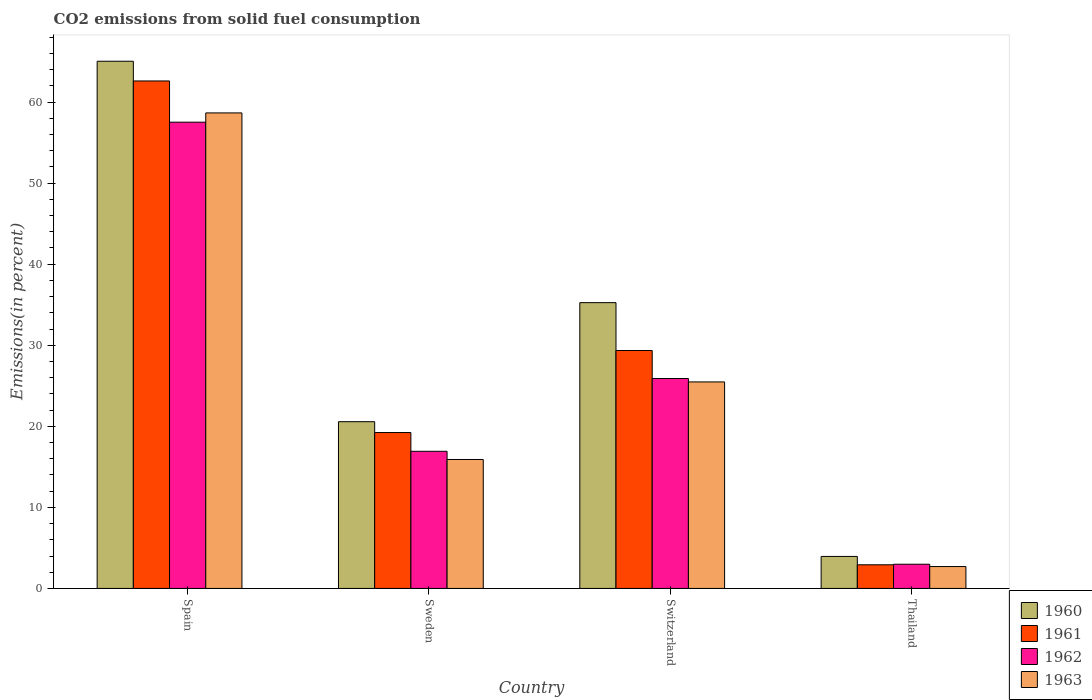How many bars are there on the 3rd tick from the left?
Your answer should be compact. 4. What is the label of the 1st group of bars from the left?
Offer a very short reply. Spain. What is the total CO2 emitted in 1961 in Spain?
Keep it short and to the point. 62.6. Across all countries, what is the maximum total CO2 emitted in 1962?
Give a very brief answer. 57.52. Across all countries, what is the minimum total CO2 emitted in 1961?
Provide a short and direct response. 2.92. In which country was the total CO2 emitted in 1960 minimum?
Ensure brevity in your answer.  Thailand. What is the total total CO2 emitted in 1960 in the graph?
Keep it short and to the point. 124.81. What is the difference between the total CO2 emitted in 1962 in Switzerland and that in Thailand?
Provide a short and direct response. 22.91. What is the difference between the total CO2 emitted in 1961 in Sweden and the total CO2 emitted in 1963 in Spain?
Your answer should be very brief. -39.43. What is the average total CO2 emitted in 1963 per country?
Give a very brief answer. 25.69. What is the difference between the total CO2 emitted of/in 1963 and total CO2 emitted of/in 1961 in Switzerland?
Provide a succinct answer. -3.88. In how many countries, is the total CO2 emitted in 1963 greater than 22 %?
Your response must be concise. 2. What is the ratio of the total CO2 emitted in 1963 in Sweden to that in Switzerland?
Your answer should be compact. 0.62. Is the total CO2 emitted in 1960 in Sweden less than that in Switzerland?
Your answer should be very brief. Yes. What is the difference between the highest and the second highest total CO2 emitted in 1961?
Give a very brief answer. -10.12. What is the difference between the highest and the lowest total CO2 emitted in 1960?
Your answer should be very brief. 61.09. Is the sum of the total CO2 emitted in 1960 in Sweden and Switzerland greater than the maximum total CO2 emitted in 1963 across all countries?
Offer a terse response. No. What does the 2nd bar from the left in Thailand represents?
Your response must be concise. 1961. What does the 2nd bar from the right in Spain represents?
Your response must be concise. 1962. How many bars are there?
Keep it short and to the point. 16. Are all the bars in the graph horizontal?
Make the answer very short. No. What is the difference between two consecutive major ticks on the Y-axis?
Offer a very short reply. 10. Does the graph contain any zero values?
Provide a succinct answer. No. How many legend labels are there?
Your answer should be very brief. 4. What is the title of the graph?
Keep it short and to the point. CO2 emissions from solid fuel consumption. What is the label or title of the Y-axis?
Your answer should be compact. Emissions(in percent). What is the Emissions(in percent) in 1960 in Spain?
Offer a terse response. 65.04. What is the Emissions(in percent) of 1961 in Spain?
Ensure brevity in your answer.  62.6. What is the Emissions(in percent) of 1962 in Spain?
Your response must be concise. 57.52. What is the Emissions(in percent) in 1963 in Spain?
Ensure brevity in your answer.  58.66. What is the Emissions(in percent) of 1960 in Sweden?
Keep it short and to the point. 20.57. What is the Emissions(in percent) of 1961 in Sweden?
Your answer should be compact. 19.23. What is the Emissions(in percent) in 1962 in Sweden?
Your response must be concise. 16.92. What is the Emissions(in percent) in 1963 in Sweden?
Ensure brevity in your answer.  15.91. What is the Emissions(in percent) of 1960 in Switzerland?
Your response must be concise. 35.26. What is the Emissions(in percent) in 1961 in Switzerland?
Offer a terse response. 29.35. What is the Emissions(in percent) of 1962 in Switzerland?
Offer a very short reply. 25.9. What is the Emissions(in percent) in 1963 in Switzerland?
Your response must be concise. 25.48. What is the Emissions(in percent) of 1960 in Thailand?
Provide a succinct answer. 3.95. What is the Emissions(in percent) of 1961 in Thailand?
Provide a succinct answer. 2.92. What is the Emissions(in percent) in 1962 in Thailand?
Ensure brevity in your answer.  2.99. What is the Emissions(in percent) in 1963 in Thailand?
Make the answer very short. 2.7. Across all countries, what is the maximum Emissions(in percent) in 1960?
Make the answer very short. 65.04. Across all countries, what is the maximum Emissions(in percent) of 1961?
Give a very brief answer. 62.6. Across all countries, what is the maximum Emissions(in percent) in 1962?
Keep it short and to the point. 57.52. Across all countries, what is the maximum Emissions(in percent) in 1963?
Keep it short and to the point. 58.66. Across all countries, what is the minimum Emissions(in percent) in 1960?
Keep it short and to the point. 3.95. Across all countries, what is the minimum Emissions(in percent) of 1961?
Provide a short and direct response. 2.92. Across all countries, what is the minimum Emissions(in percent) of 1962?
Your answer should be very brief. 2.99. Across all countries, what is the minimum Emissions(in percent) of 1963?
Your response must be concise. 2.7. What is the total Emissions(in percent) of 1960 in the graph?
Offer a very short reply. 124.81. What is the total Emissions(in percent) of 1961 in the graph?
Offer a terse response. 114.11. What is the total Emissions(in percent) of 1962 in the graph?
Offer a terse response. 103.32. What is the total Emissions(in percent) of 1963 in the graph?
Your response must be concise. 102.74. What is the difference between the Emissions(in percent) of 1960 in Spain and that in Sweden?
Your response must be concise. 44.47. What is the difference between the Emissions(in percent) of 1961 in Spain and that in Sweden?
Make the answer very short. 43.37. What is the difference between the Emissions(in percent) in 1962 in Spain and that in Sweden?
Make the answer very short. 40.6. What is the difference between the Emissions(in percent) in 1963 in Spain and that in Sweden?
Provide a succinct answer. 42.75. What is the difference between the Emissions(in percent) of 1960 in Spain and that in Switzerland?
Ensure brevity in your answer.  29.78. What is the difference between the Emissions(in percent) of 1961 in Spain and that in Switzerland?
Provide a short and direct response. 33.25. What is the difference between the Emissions(in percent) in 1962 in Spain and that in Switzerland?
Make the answer very short. 31.62. What is the difference between the Emissions(in percent) in 1963 in Spain and that in Switzerland?
Make the answer very short. 33.19. What is the difference between the Emissions(in percent) in 1960 in Spain and that in Thailand?
Make the answer very short. 61.09. What is the difference between the Emissions(in percent) in 1961 in Spain and that in Thailand?
Your answer should be compact. 59.69. What is the difference between the Emissions(in percent) in 1962 in Spain and that in Thailand?
Keep it short and to the point. 54.53. What is the difference between the Emissions(in percent) in 1963 in Spain and that in Thailand?
Offer a very short reply. 55.96. What is the difference between the Emissions(in percent) of 1960 in Sweden and that in Switzerland?
Your response must be concise. -14.69. What is the difference between the Emissions(in percent) in 1961 in Sweden and that in Switzerland?
Provide a short and direct response. -10.12. What is the difference between the Emissions(in percent) of 1962 in Sweden and that in Switzerland?
Provide a short and direct response. -8.98. What is the difference between the Emissions(in percent) in 1963 in Sweden and that in Switzerland?
Ensure brevity in your answer.  -9.57. What is the difference between the Emissions(in percent) of 1960 in Sweden and that in Thailand?
Provide a short and direct response. 16.62. What is the difference between the Emissions(in percent) in 1961 in Sweden and that in Thailand?
Your answer should be very brief. 16.31. What is the difference between the Emissions(in percent) in 1962 in Sweden and that in Thailand?
Your answer should be very brief. 13.93. What is the difference between the Emissions(in percent) of 1963 in Sweden and that in Thailand?
Make the answer very short. 13.21. What is the difference between the Emissions(in percent) of 1960 in Switzerland and that in Thailand?
Give a very brief answer. 31.31. What is the difference between the Emissions(in percent) in 1961 in Switzerland and that in Thailand?
Make the answer very short. 26.43. What is the difference between the Emissions(in percent) of 1962 in Switzerland and that in Thailand?
Ensure brevity in your answer.  22.91. What is the difference between the Emissions(in percent) in 1963 in Switzerland and that in Thailand?
Provide a short and direct response. 22.78. What is the difference between the Emissions(in percent) in 1960 in Spain and the Emissions(in percent) in 1961 in Sweden?
Ensure brevity in your answer.  45.81. What is the difference between the Emissions(in percent) in 1960 in Spain and the Emissions(in percent) in 1962 in Sweden?
Offer a very short reply. 48.12. What is the difference between the Emissions(in percent) of 1960 in Spain and the Emissions(in percent) of 1963 in Sweden?
Your answer should be very brief. 49.13. What is the difference between the Emissions(in percent) of 1961 in Spain and the Emissions(in percent) of 1962 in Sweden?
Give a very brief answer. 45.69. What is the difference between the Emissions(in percent) of 1961 in Spain and the Emissions(in percent) of 1963 in Sweden?
Offer a terse response. 46.7. What is the difference between the Emissions(in percent) of 1962 in Spain and the Emissions(in percent) of 1963 in Sweden?
Your answer should be very brief. 41.61. What is the difference between the Emissions(in percent) of 1960 in Spain and the Emissions(in percent) of 1961 in Switzerland?
Keep it short and to the point. 35.69. What is the difference between the Emissions(in percent) of 1960 in Spain and the Emissions(in percent) of 1962 in Switzerland?
Ensure brevity in your answer.  39.14. What is the difference between the Emissions(in percent) of 1960 in Spain and the Emissions(in percent) of 1963 in Switzerland?
Your answer should be compact. 39.56. What is the difference between the Emissions(in percent) in 1961 in Spain and the Emissions(in percent) in 1962 in Switzerland?
Offer a terse response. 36.7. What is the difference between the Emissions(in percent) of 1961 in Spain and the Emissions(in percent) of 1963 in Switzerland?
Offer a terse response. 37.13. What is the difference between the Emissions(in percent) in 1962 in Spain and the Emissions(in percent) in 1963 in Switzerland?
Your answer should be compact. 32.04. What is the difference between the Emissions(in percent) of 1960 in Spain and the Emissions(in percent) of 1961 in Thailand?
Provide a succinct answer. 62.12. What is the difference between the Emissions(in percent) in 1960 in Spain and the Emissions(in percent) in 1962 in Thailand?
Ensure brevity in your answer.  62.05. What is the difference between the Emissions(in percent) of 1960 in Spain and the Emissions(in percent) of 1963 in Thailand?
Offer a very short reply. 62.34. What is the difference between the Emissions(in percent) of 1961 in Spain and the Emissions(in percent) of 1962 in Thailand?
Make the answer very short. 59.62. What is the difference between the Emissions(in percent) in 1961 in Spain and the Emissions(in percent) in 1963 in Thailand?
Your response must be concise. 59.91. What is the difference between the Emissions(in percent) in 1962 in Spain and the Emissions(in percent) in 1963 in Thailand?
Make the answer very short. 54.82. What is the difference between the Emissions(in percent) of 1960 in Sweden and the Emissions(in percent) of 1961 in Switzerland?
Keep it short and to the point. -8.78. What is the difference between the Emissions(in percent) in 1960 in Sweden and the Emissions(in percent) in 1962 in Switzerland?
Your answer should be very brief. -5.33. What is the difference between the Emissions(in percent) in 1960 in Sweden and the Emissions(in percent) in 1963 in Switzerland?
Your answer should be very brief. -4.91. What is the difference between the Emissions(in percent) in 1961 in Sweden and the Emissions(in percent) in 1962 in Switzerland?
Keep it short and to the point. -6.67. What is the difference between the Emissions(in percent) of 1961 in Sweden and the Emissions(in percent) of 1963 in Switzerland?
Make the answer very short. -6.24. What is the difference between the Emissions(in percent) of 1962 in Sweden and the Emissions(in percent) of 1963 in Switzerland?
Make the answer very short. -8.56. What is the difference between the Emissions(in percent) in 1960 in Sweden and the Emissions(in percent) in 1961 in Thailand?
Ensure brevity in your answer.  17.65. What is the difference between the Emissions(in percent) in 1960 in Sweden and the Emissions(in percent) in 1962 in Thailand?
Your response must be concise. 17.58. What is the difference between the Emissions(in percent) in 1960 in Sweden and the Emissions(in percent) in 1963 in Thailand?
Your answer should be compact. 17.87. What is the difference between the Emissions(in percent) of 1961 in Sweden and the Emissions(in percent) of 1962 in Thailand?
Offer a terse response. 16.25. What is the difference between the Emissions(in percent) of 1961 in Sweden and the Emissions(in percent) of 1963 in Thailand?
Ensure brevity in your answer.  16.53. What is the difference between the Emissions(in percent) of 1962 in Sweden and the Emissions(in percent) of 1963 in Thailand?
Provide a succinct answer. 14.22. What is the difference between the Emissions(in percent) in 1960 in Switzerland and the Emissions(in percent) in 1961 in Thailand?
Provide a succinct answer. 32.34. What is the difference between the Emissions(in percent) of 1960 in Switzerland and the Emissions(in percent) of 1962 in Thailand?
Provide a short and direct response. 32.27. What is the difference between the Emissions(in percent) in 1960 in Switzerland and the Emissions(in percent) in 1963 in Thailand?
Ensure brevity in your answer.  32.56. What is the difference between the Emissions(in percent) in 1961 in Switzerland and the Emissions(in percent) in 1962 in Thailand?
Your answer should be compact. 26.37. What is the difference between the Emissions(in percent) in 1961 in Switzerland and the Emissions(in percent) in 1963 in Thailand?
Your answer should be very brief. 26.65. What is the difference between the Emissions(in percent) in 1962 in Switzerland and the Emissions(in percent) in 1963 in Thailand?
Offer a terse response. 23.2. What is the average Emissions(in percent) in 1960 per country?
Provide a short and direct response. 31.2. What is the average Emissions(in percent) in 1961 per country?
Make the answer very short. 28.53. What is the average Emissions(in percent) in 1962 per country?
Provide a short and direct response. 25.83. What is the average Emissions(in percent) in 1963 per country?
Provide a short and direct response. 25.69. What is the difference between the Emissions(in percent) of 1960 and Emissions(in percent) of 1961 in Spain?
Offer a terse response. 2.43. What is the difference between the Emissions(in percent) in 1960 and Emissions(in percent) in 1962 in Spain?
Keep it short and to the point. 7.52. What is the difference between the Emissions(in percent) of 1960 and Emissions(in percent) of 1963 in Spain?
Offer a terse response. 6.38. What is the difference between the Emissions(in percent) of 1961 and Emissions(in percent) of 1962 in Spain?
Offer a terse response. 5.08. What is the difference between the Emissions(in percent) of 1961 and Emissions(in percent) of 1963 in Spain?
Provide a succinct answer. 3.94. What is the difference between the Emissions(in percent) in 1962 and Emissions(in percent) in 1963 in Spain?
Your answer should be very brief. -1.14. What is the difference between the Emissions(in percent) in 1960 and Emissions(in percent) in 1961 in Sweden?
Provide a short and direct response. 1.34. What is the difference between the Emissions(in percent) of 1960 and Emissions(in percent) of 1962 in Sweden?
Make the answer very short. 3.65. What is the difference between the Emissions(in percent) in 1960 and Emissions(in percent) in 1963 in Sweden?
Provide a succinct answer. 4.66. What is the difference between the Emissions(in percent) of 1961 and Emissions(in percent) of 1962 in Sweden?
Make the answer very short. 2.31. What is the difference between the Emissions(in percent) in 1961 and Emissions(in percent) in 1963 in Sweden?
Make the answer very short. 3.32. What is the difference between the Emissions(in percent) in 1962 and Emissions(in percent) in 1963 in Sweden?
Your answer should be compact. 1.01. What is the difference between the Emissions(in percent) of 1960 and Emissions(in percent) of 1961 in Switzerland?
Your answer should be compact. 5.9. What is the difference between the Emissions(in percent) in 1960 and Emissions(in percent) in 1962 in Switzerland?
Offer a very short reply. 9.36. What is the difference between the Emissions(in percent) of 1960 and Emissions(in percent) of 1963 in Switzerland?
Give a very brief answer. 9.78. What is the difference between the Emissions(in percent) in 1961 and Emissions(in percent) in 1962 in Switzerland?
Your answer should be compact. 3.45. What is the difference between the Emissions(in percent) of 1961 and Emissions(in percent) of 1963 in Switzerland?
Make the answer very short. 3.88. What is the difference between the Emissions(in percent) in 1962 and Emissions(in percent) in 1963 in Switzerland?
Provide a succinct answer. 0.42. What is the difference between the Emissions(in percent) of 1960 and Emissions(in percent) of 1961 in Thailand?
Give a very brief answer. 1.03. What is the difference between the Emissions(in percent) of 1960 and Emissions(in percent) of 1962 in Thailand?
Offer a terse response. 0.96. What is the difference between the Emissions(in percent) in 1960 and Emissions(in percent) in 1963 in Thailand?
Your answer should be compact. 1.25. What is the difference between the Emissions(in percent) in 1961 and Emissions(in percent) in 1962 in Thailand?
Provide a short and direct response. -0.07. What is the difference between the Emissions(in percent) of 1961 and Emissions(in percent) of 1963 in Thailand?
Offer a very short reply. 0.22. What is the difference between the Emissions(in percent) in 1962 and Emissions(in percent) in 1963 in Thailand?
Offer a very short reply. 0.29. What is the ratio of the Emissions(in percent) in 1960 in Spain to that in Sweden?
Ensure brevity in your answer.  3.16. What is the ratio of the Emissions(in percent) of 1961 in Spain to that in Sweden?
Your response must be concise. 3.26. What is the ratio of the Emissions(in percent) in 1962 in Spain to that in Sweden?
Keep it short and to the point. 3.4. What is the ratio of the Emissions(in percent) in 1963 in Spain to that in Sweden?
Ensure brevity in your answer.  3.69. What is the ratio of the Emissions(in percent) in 1960 in Spain to that in Switzerland?
Offer a very short reply. 1.84. What is the ratio of the Emissions(in percent) in 1961 in Spain to that in Switzerland?
Your answer should be compact. 2.13. What is the ratio of the Emissions(in percent) in 1962 in Spain to that in Switzerland?
Keep it short and to the point. 2.22. What is the ratio of the Emissions(in percent) in 1963 in Spain to that in Switzerland?
Offer a terse response. 2.3. What is the ratio of the Emissions(in percent) in 1960 in Spain to that in Thailand?
Keep it short and to the point. 16.47. What is the ratio of the Emissions(in percent) in 1961 in Spain to that in Thailand?
Provide a succinct answer. 21.46. What is the ratio of the Emissions(in percent) in 1962 in Spain to that in Thailand?
Provide a short and direct response. 19.26. What is the ratio of the Emissions(in percent) of 1963 in Spain to that in Thailand?
Provide a succinct answer. 21.73. What is the ratio of the Emissions(in percent) in 1960 in Sweden to that in Switzerland?
Make the answer very short. 0.58. What is the ratio of the Emissions(in percent) of 1961 in Sweden to that in Switzerland?
Keep it short and to the point. 0.66. What is the ratio of the Emissions(in percent) in 1962 in Sweden to that in Switzerland?
Keep it short and to the point. 0.65. What is the ratio of the Emissions(in percent) of 1963 in Sweden to that in Switzerland?
Provide a short and direct response. 0.62. What is the ratio of the Emissions(in percent) in 1960 in Sweden to that in Thailand?
Offer a very short reply. 5.21. What is the ratio of the Emissions(in percent) in 1961 in Sweden to that in Thailand?
Make the answer very short. 6.59. What is the ratio of the Emissions(in percent) in 1962 in Sweden to that in Thailand?
Offer a very short reply. 5.67. What is the ratio of the Emissions(in percent) in 1963 in Sweden to that in Thailand?
Your response must be concise. 5.89. What is the ratio of the Emissions(in percent) of 1960 in Switzerland to that in Thailand?
Your answer should be compact. 8.93. What is the ratio of the Emissions(in percent) in 1961 in Switzerland to that in Thailand?
Offer a very short reply. 10.06. What is the ratio of the Emissions(in percent) in 1962 in Switzerland to that in Thailand?
Your response must be concise. 8.67. What is the ratio of the Emissions(in percent) in 1963 in Switzerland to that in Thailand?
Your response must be concise. 9.44. What is the difference between the highest and the second highest Emissions(in percent) of 1960?
Offer a terse response. 29.78. What is the difference between the highest and the second highest Emissions(in percent) in 1961?
Give a very brief answer. 33.25. What is the difference between the highest and the second highest Emissions(in percent) in 1962?
Your answer should be compact. 31.62. What is the difference between the highest and the second highest Emissions(in percent) of 1963?
Make the answer very short. 33.19. What is the difference between the highest and the lowest Emissions(in percent) in 1960?
Give a very brief answer. 61.09. What is the difference between the highest and the lowest Emissions(in percent) in 1961?
Offer a very short reply. 59.69. What is the difference between the highest and the lowest Emissions(in percent) of 1962?
Your answer should be very brief. 54.53. What is the difference between the highest and the lowest Emissions(in percent) of 1963?
Your response must be concise. 55.96. 